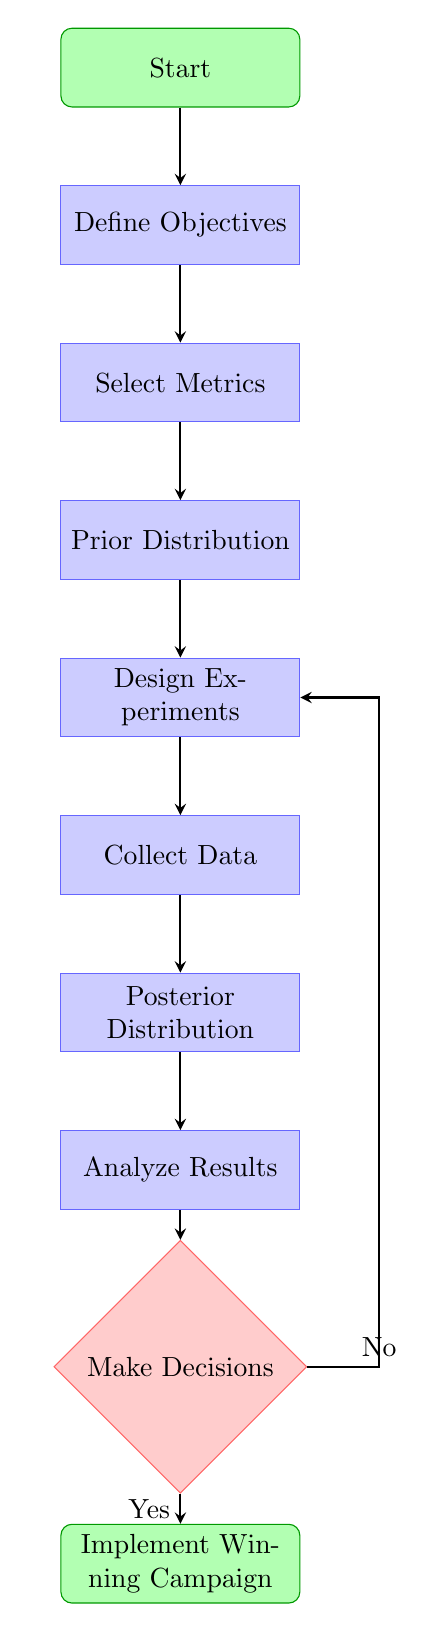What is the first step in the process? The first step in the diagram is "Start," which initiates the Bayesian A/B Testing Process.
Answer: Start How many processes are there in the diagram? Counting all the nodes marked as processes, there are a total of six: Define Objectives, Select Metrics, Prior Distribution, Design Experiments, Collect Data, Posterior Distribution, and Analyze Results.
Answer: 6 What is the last step in the process? The last step in the diagram is "Implement Winning Campaign," which is the outcome of the A/B testing process.
Answer: Implement Winning Campaign What decision follows the "Analyze Results" step? After analyzing the results, the decision point is "Make Decisions," which determines the next actions based on the analysis results.
Answer: Make Decisions If the decision is 'No,' where does it lead? If the decision is 'No', the process loops back to "Design Experiments," indicating that variations need to be tested again.
Answer: Design Experiments How many key performance indicators are chosen in the "Select Metrics" step? The diagram does not specify a number; it simply indicates that key performance indicators are chosen, which can be one or more metrics like CTR or conversion rate.
Answer: Unspecified What is combined to obtain the posterior distribution? The posterior distribution is obtained by combining the prior distribution with the collected data from the campaign.
Answer: Prior distribution and data What is the purpose of the "Collect Data" step? The purpose of the "Collect Data" step is to run the campaign and gather response data necessary for analysis.
Answer: Gather response data 